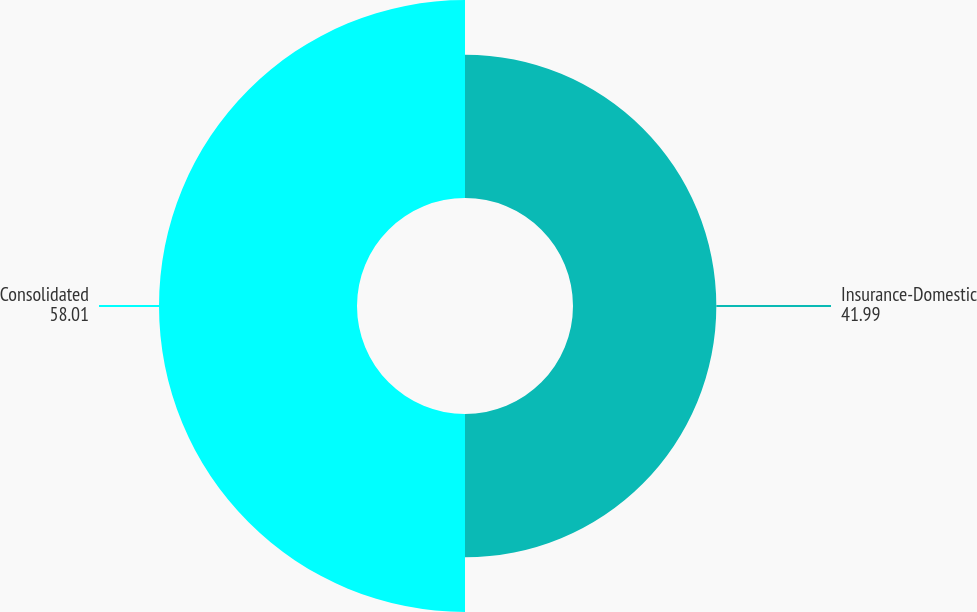Convert chart. <chart><loc_0><loc_0><loc_500><loc_500><pie_chart><fcel>Insurance-Domestic<fcel>Consolidated<nl><fcel>41.99%<fcel>58.01%<nl></chart> 